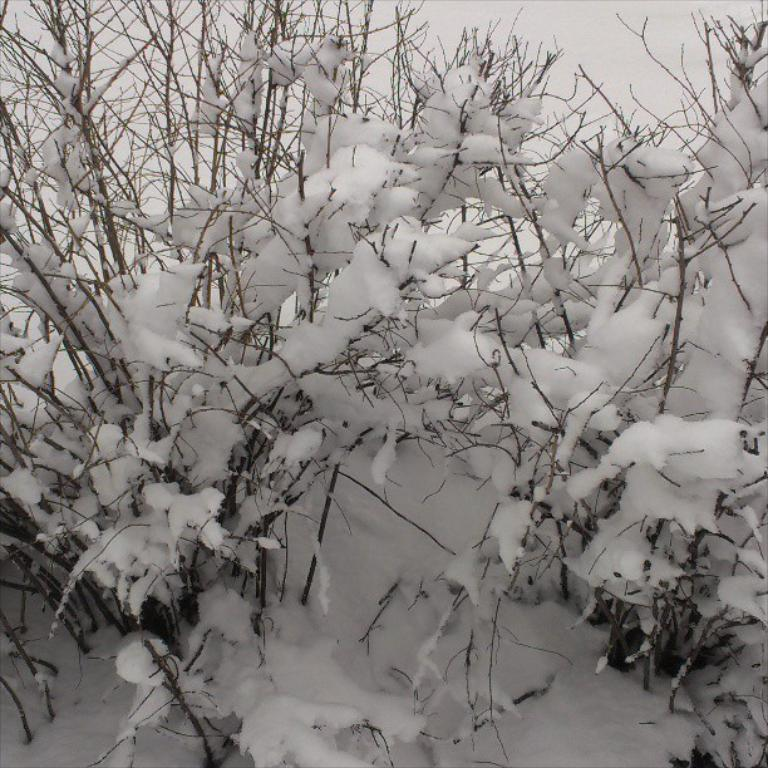What type of living organisms can be seen in the image? Plants can be seen in the image. How are the plants in the image affected by the weather? The plants are covered with snow, indicating cold weather. How many trains can be seen passing by the plants in the image? There are no trains visible in the image; it only features plants covered with snow. 